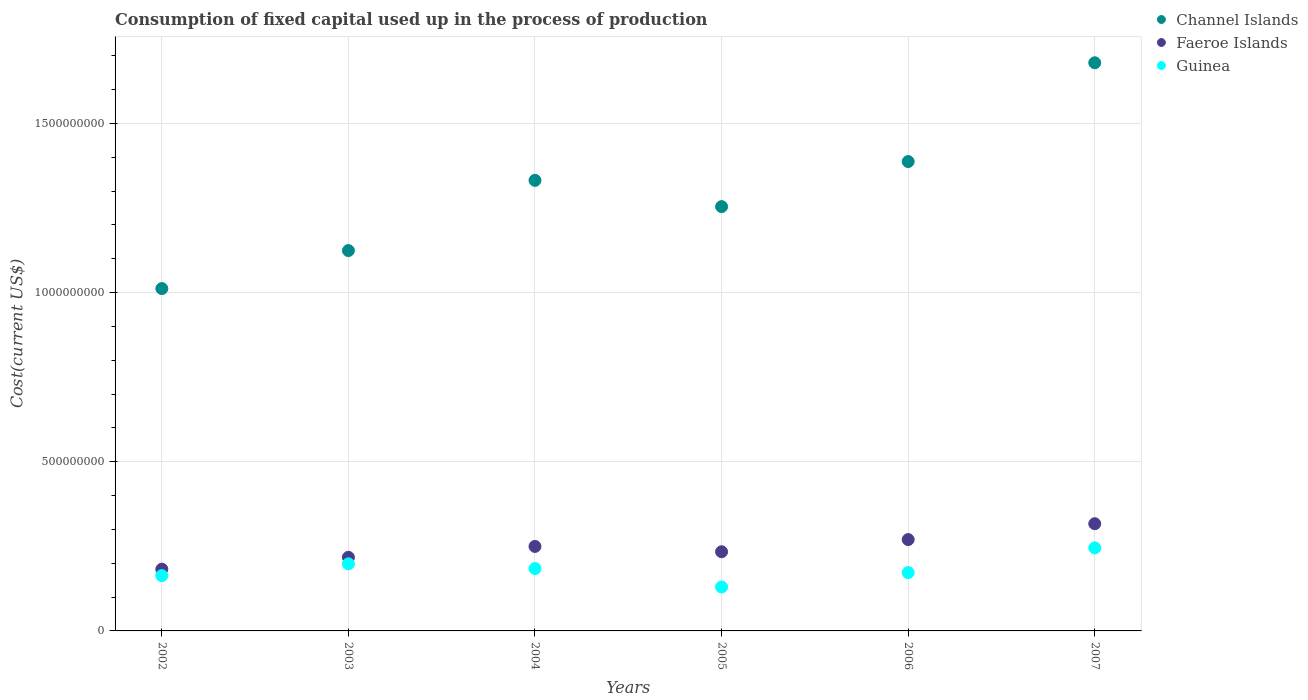Is the number of dotlines equal to the number of legend labels?
Provide a succinct answer. Yes. What is the amount consumed in the process of production in Guinea in 2005?
Your answer should be very brief. 1.30e+08. Across all years, what is the maximum amount consumed in the process of production in Channel Islands?
Ensure brevity in your answer.  1.68e+09. Across all years, what is the minimum amount consumed in the process of production in Faeroe Islands?
Your answer should be very brief. 1.83e+08. In which year was the amount consumed in the process of production in Faeroe Islands minimum?
Keep it short and to the point. 2002. What is the total amount consumed in the process of production in Guinea in the graph?
Keep it short and to the point. 1.09e+09. What is the difference between the amount consumed in the process of production in Faeroe Islands in 2003 and that in 2006?
Offer a very short reply. -5.24e+07. What is the difference between the amount consumed in the process of production in Channel Islands in 2006 and the amount consumed in the process of production in Guinea in 2003?
Provide a succinct answer. 1.19e+09. What is the average amount consumed in the process of production in Channel Islands per year?
Ensure brevity in your answer.  1.30e+09. In the year 2003, what is the difference between the amount consumed in the process of production in Guinea and amount consumed in the process of production in Channel Islands?
Your answer should be very brief. -9.26e+08. What is the ratio of the amount consumed in the process of production in Channel Islands in 2003 to that in 2006?
Offer a terse response. 0.81. What is the difference between the highest and the second highest amount consumed in the process of production in Channel Islands?
Keep it short and to the point. 2.92e+08. What is the difference between the highest and the lowest amount consumed in the process of production in Channel Islands?
Your answer should be very brief. 6.67e+08. Is it the case that in every year, the sum of the amount consumed in the process of production in Faeroe Islands and amount consumed in the process of production in Guinea  is greater than the amount consumed in the process of production in Channel Islands?
Make the answer very short. No. Is the amount consumed in the process of production in Guinea strictly greater than the amount consumed in the process of production in Channel Islands over the years?
Give a very brief answer. No. How many years are there in the graph?
Your response must be concise. 6. Does the graph contain any zero values?
Provide a short and direct response. No. Does the graph contain grids?
Keep it short and to the point. Yes. How many legend labels are there?
Offer a very short reply. 3. How are the legend labels stacked?
Give a very brief answer. Vertical. What is the title of the graph?
Ensure brevity in your answer.  Consumption of fixed capital used up in the process of production. Does "Turkmenistan" appear as one of the legend labels in the graph?
Provide a succinct answer. No. What is the label or title of the X-axis?
Make the answer very short. Years. What is the label or title of the Y-axis?
Ensure brevity in your answer.  Cost(current US$). What is the Cost(current US$) of Channel Islands in 2002?
Keep it short and to the point. 1.01e+09. What is the Cost(current US$) in Faeroe Islands in 2002?
Make the answer very short. 1.83e+08. What is the Cost(current US$) of Guinea in 2002?
Offer a terse response. 1.63e+08. What is the Cost(current US$) in Channel Islands in 2003?
Keep it short and to the point. 1.12e+09. What is the Cost(current US$) of Faeroe Islands in 2003?
Provide a succinct answer. 2.18e+08. What is the Cost(current US$) in Guinea in 2003?
Offer a terse response. 1.98e+08. What is the Cost(current US$) of Channel Islands in 2004?
Keep it short and to the point. 1.33e+09. What is the Cost(current US$) of Faeroe Islands in 2004?
Provide a short and direct response. 2.50e+08. What is the Cost(current US$) of Guinea in 2004?
Provide a short and direct response. 1.84e+08. What is the Cost(current US$) of Channel Islands in 2005?
Your answer should be very brief. 1.25e+09. What is the Cost(current US$) in Faeroe Islands in 2005?
Provide a short and direct response. 2.34e+08. What is the Cost(current US$) in Guinea in 2005?
Offer a very short reply. 1.30e+08. What is the Cost(current US$) of Channel Islands in 2006?
Keep it short and to the point. 1.39e+09. What is the Cost(current US$) of Faeroe Islands in 2006?
Offer a terse response. 2.70e+08. What is the Cost(current US$) in Guinea in 2006?
Keep it short and to the point. 1.72e+08. What is the Cost(current US$) in Channel Islands in 2007?
Your response must be concise. 1.68e+09. What is the Cost(current US$) in Faeroe Islands in 2007?
Offer a very short reply. 3.17e+08. What is the Cost(current US$) of Guinea in 2007?
Offer a terse response. 2.46e+08. Across all years, what is the maximum Cost(current US$) of Channel Islands?
Your answer should be very brief. 1.68e+09. Across all years, what is the maximum Cost(current US$) in Faeroe Islands?
Your answer should be very brief. 3.17e+08. Across all years, what is the maximum Cost(current US$) in Guinea?
Make the answer very short. 2.46e+08. Across all years, what is the minimum Cost(current US$) in Channel Islands?
Offer a terse response. 1.01e+09. Across all years, what is the minimum Cost(current US$) in Faeroe Islands?
Ensure brevity in your answer.  1.83e+08. Across all years, what is the minimum Cost(current US$) in Guinea?
Keep it short and to the point. 1.30e+08. What is the total Cost(current US$) in Channel Islands in the graph?
Your answer should be compact. 7.79e+09. What is the total Cost(current US$) in Faeroe Islands in the graph?
Keep it short and to the point. 1.47e+09. What is the total Cost(current US$) in Guinea in the graph?
Keep it short and to the point. 1.09e+09. What is the difference between the Cost(current US$) of Channel Islands in 2002 and that in 2003?
Make the answer very short. -1.12e+08. What is the difference between the Cost(current US$) in Faeroe Islands in 2002 and that in 2003?
Your answer should be very brief. -3.51e+07. What is the difference between the Cost(current US$) in Guinea in 2002 and that in 2003?
Your answer should be compact. -3.49e+07. What is the difference between the Cost(current US$) of Channel Islands in 2002 and that in 2004?
Make the answer very short. -3.20e+08. What is the difference between the Cost(current US$) in Faeroe Islands in 2002 and that in 2004?
Ensure brevity in your answer.  -6.72e+07. What is the difference between the Cost(current US$) of Guinea in 2002 and that in 2004?
Ensure brevity in your answer.  -2.11e+07. What is the difference between the Cost(current US$) of Channel Islands in 2002 and that in 2005?
Your answer should be very brief. -2.42e+08. What is the difference between the Cost(current US$) of Faeroe Islands in 2002 and that in 2005?
Your response must be concise. -5.15e+07. What is the difference between the Cost(current US$) in Guinea in 2002 and that in 2005?
Offer a terse response. 3.35e+07. What is the difference between the Cost(current US$) in Channel Islands in 2002 and that in 2006?
Keep it short and to the point. -3.76e+08. What is the difference between the Cost(current US$) in Faeroe Islands in 2002 and that in 2006?
Your answer should be very brief. -8.75e+07. What is the difference between the Cost(current US$) of Guinea in 2002 and that in 2006?
Your answer should be compact. -8.97e+06. What is the difference between the Cost(current US$) in Channel Islands in 2002 and that in 2007?
Make the answer very short. -6.67e+08. What is the difference between the Cost(current US$) of Faeroe Islands in 2002 and that in 2007?
Provide a succinct answer. -1.34e+08. What is the difference between the Cost(current US$) in Guinea in 2002 and that in 2007?
Your answer should be compact. -8.22e+07. What is the difference between the Cost(current US$) in Channel Islands in 2003 and that in 2004?
Offer a terse response. -2.08e+08. What is the difference between the Cost(current US$) of Faeroe Islands in 2003 and that in 2004?
Offer a terse response. -3.21e+07. What is the difference between the Cost(current US$) in Guinea in 2003 and that in 2004?
Your response must be concise. 1.39e+07. What is the difference between the Cost(current US$) of Channel Islands in 2003 and that in 2005?
Make the answer very short. -1.30e+08. What is the difference between the Cost(current US$) in Faeroe Islands in 2003 and that in 2005?
Give a very brief answer. -1.64e+07. What is the difference between the Cost(current US$) in Guinea in 2003 and that in 2005?
Your response must be concise. 6.85e+07. What is the difference between the Cost(current US$) in Channel Islands in 2003 and that in 2006?
Offer a terse response. -2.63e+08. What is the difference between the Cost(current US$) of Faeroe Islands in 2003 and that in 2006?
Provide a short and direct response. -5.24e+07. What is the difference between the Cost(current US$) of Guinea in 2003 and that in 2006?
Make the answer very short. 2.60e+07. What is the difference between the Cost(current US$) in Channel Islands in 2003 and that in 2007?
Keep it short and to the point. -5.55e+08. What is the difference between the Cost(current US$) of Faeroe Islands in 2003 and that in 2007?
Give a very brief answer. -9.93e+07. What is the difference between the Cost(current US$) of Guinea in 2003 and that in 2007?
Provide a succinct answer. -4.72e+07. What is the difference between the Cost(current US$) in Channel Islands in 2004 and that in 2005?
Provide a short and direct response. 7.76e+07. What is the difference between the Cost(current US$) in Faeroe Islands in 2004 and that in 2005?
Make the answer very short. 1.57e+07. What is the difference between the Cost(current US$) in Guinea in 2004 and that in 2005?
Offer a terse response. 5.46e+07. What is the difference between the Cost(current US$) in Channel Islands in 2004 and that in 2006?
Offer a very short reply. -5.56e+07. What is the difference between the Cost(current US$) in Faeroe Islands in 2004 and that in 2006?
Keep it short and to the point. -2.03e+07. What is the difference between the Cost(current US$) in Guinea in 2004 and that in 2006?
Provide a succinct answer. 1.21e+07. What is the difference between the Cost(current US$) in Channel Islands in 2004 and that in 2007?
Your answer should be compact. -3.48e+08. What is the difference between the Cost(current US$) of Faeroe Islands in 2004 and that in 2007?
Your answer should be compact. -6.72e+07. What is the difference between the Cost(current US$) in Guinea in 2004 and that in 2007?
Offer a very short reply. -6.11e+07. What is the difference between the Cost(current US$) in Channel Islands in 2005 and that in 2006?
Provide a succinct answer. -1.33e+08. What is the difference between the Cost(current US$) in Faeroe Islands in 2005 and that in 2006?
Ensure brevity in your answer.  -3.60e+07. What is the difference between the Cost(current US$) of Guinea in 2005 and that in 2006?
Your answer should be very brief. -4.25e+07. What is the difference between the Cost(current US$) of Channel Islands in 2005 and that in 2007?
Your answer should be very brief. -4.25e+08. What is the difference between the Cost(current US$) in Faeroe Islands in 2005 and that in 2007?
Keep it short and to the point. -8.29e+07. What is the difference between the Cost(current US$) in Guinea in 2005 and that in 2007?
Your response must be concise. -1.16e+08. What is the difference between the Cost(current US$) in Channel Islands in 2006 and that in 2007?
Offer a terse response. -2.92e+08. What is the difference between the Cost(current US$) of Faeroe Islands in 2006 and that in 2007?
Give a very brief answer. -4.69e+07. What is the difference between the Cost(current US$) in Guinea in 2006 and that in 2007?
Provide a succinct answer. -7.32e+07. What is the difference between the Cost(current US$) of Channel Islands in 2002 and the Cost(current US$) of Faeroe Islands in 2003?
Ensure brevity in your answer.  7.94e+08. What is the difference between the Cost(current US$) of Channel Islands in 2002 and the Cost(current US$) of Guinea in 2003?
Your answer should be very brief. 8.14e+08. What is the difference between the Cost(current US$) of Faeroe Islands in 2002 and the Cost(current US$) of Guinea in 2003?
Provide a succinct answer. -1.58e+07. What is the difference between the Cost(current US$) of Channel Islands in 2002 and the Cost(current US$) of Faeroe Islands in 2004?
Make the answer very short. 7.62e+08. What is the difference between the Cost(current US$) of Channel Islands in 2002 and the Cost(current US$) of Guinea in 2004?
Your response must be concise. 8.27e+08. What is the difference between the Cost(current US$) in Faeroe Islands in 2002 and the Cost(current US$) in Guinea in 2004?
Your answer should be compact. -1.89e+06. What is the difference between the Cost(current US$) in Channel Islands in 2002 and the Cost(current US$) in Faeroe Islands in 2005?
Your answer should be very brief. 7.78e+08. What is the difference between the Cost(current US$) in Channel Islands in 2002 and the Cost(current US$) in Guinea in 2005?
Offer a terse response. 8.82e+08. What is the difference between the Cost(current US$) of Faeroe Islands in 2002 and the Cost(current US$) of Guinea in 2005?
Give a very brief answer. 5.27e+07. What is the difference between the Cost(current US$) in Channel Islands in 2002 and the Cost(current US$) in Faeroe Islands in 2006?
Offer a terse response. 7.42e+08. What is the difference between the Cost(current US$) of Channel Islands in 2002 and the Cost(current US$) of Guinea in 2006?
Ensure brevity in your answer.  8.40e+08. What is the difference between the Cost(current US$) in Faeroe Islands in 2002 and the Cost(current US$) in Guinea in 2006?
Make the answer very short. 1.02e+07. What is the difference between the Cost(current US$) in Channel Islands in 2002 and the Cost(current US$) in Faeroe Islands in 2007?
Offer a terse response. 6.95e+08. What is the difference between the Cost(current US$) in Channel Islands in 2002 and the Cost(current US$) in Guinea in 2007?
Your answer should be compact. 7.66e+08. What is the difference between the Cost(current US$) in Faeroe Islands in 2002 and the Cost(current US$) in Guinea in 2007?
Your answer should be compact. -6.30e+07. What is the difference between the Cost(current US$) in Channel Islands in 2003 and the Cost(current US$) in Faeroe Islands in 2004?
Give a very brief answer. 8.75e+08. What is the difference between the Cost(current US$) of Channel Islands in 2003 and the Cost(current US$) of Guinea in 2004?
Your response must be concise. 9.40e+08. What is the difference between the Cost(current US$) in Faeroe Islands in 2003 and the Cost(current US$) in Guinea in 2004?
Keep it short and to the point. 3.32e+07. What is the difference between the Cost(current US$) of Channel Islands in 2003 and the Cost(current US$) of Faeroe Islands in 2005?
Your response must be concise. 8.90e+08. What is the difference between the Cost(current US$) in Channel Islands in 2003 and the Cost(current US$) in Guinea in 2005?
Give a very brief answer. 9.94e+08. What is the difference between the Cost(current US$) of Faeroe Islands in 2003 and the Cost(current US$) of Guinea in 2005?
Provide a succinct answer. 8.78e+07. What is the difference between the Cost(current US$) of Channel Islands in 2003 and the Cost(current US$) of Faeroe Islands in 2006?
Keep it short and to the point. 8.54e+08. What is the difference between the Cost(current US$) in Channel Islands in 2003 and the Cost(current US$) in Guinea in 2006?
Offer a terse response. 9.52e+08. What is the difference between the Cost(current US$) of Faeroe Islands in 2003 and the Cost(current US$) of Guinea in 2006?
Provide a short and direct response. 4.53e+07. What is the difference between the Cost(current US$) in Channel Islands in 2003 and the Cost(current US$) in Faeroe Islands in 2007?
Your answer should be compact. 8.07e+08. What is the difference between the Cost(current US$) of Channel Islands in 2003 and the Cost(current US$) of Guinea in 2007?
Your response must be concise. 8.79e+08. What is the difference between the Cost(current US$) of Faeroe Islands in 2003 and the Cost(current US$) of Guinea in 2007?
Give a very brief answer. -2.79e+07. What is the difference between the Cost(current US$) in Channel Islands in 2004 and the Cost(current US$) in Faeroe Islands in 2005?
Provide a short and direct response. 1.10e+09. What is the difference between the Cost(current US$) in Channel Islands in 2004 and the Cost(current US$) in Guinea in 2005?
Offer a terse response. 1.20e+09. What is the difference between the Cost(current US$) in Faeroe Islands in 2004 and the Cost(current US$) in Guinea in 2005?
Ensure brevity in your answer.  1.20e+08. What is the difference between the Cost(current US$) in Channel Islands in 2004 and the Cost(current US$) in Faeroe Islands in 2006?
Provide a succinct answer. 1.06e+09. What is the difference between the Cost(current US$) in Channel Islands in 2004 and the Cost(current US$) in Guinea in 2006?
Your answer should be compact. 1.16e+09. What is the difference between the Cost(current US$) in Faeroe Islands in 2004 and the Cost(current US$) in Guinea in 2006?
Ensure brevity in your answer.  7.74e+07. What is the difference between the Cost(current US$) of Channel Islands in 2004 and the Cost(current US$) of Faeroe Islands in 2007?
Your response must be concise. 1.01e+09. What is the difference between the Cost(current US$) of Channel Islands in 2004 and the Cost(current US$) of Guinea in 2007?
Offer a terse response. 1.09e+09. What is the difference between the Cost(current US$) in Faeroe Islands in 2004 and the Cost(current US$) in Guinea in 2007?
Offer a very short reply. 4.19e+06. What is the difference between the Cost(current US$) in Channel Islands in 2005 and the Cost(current US$) in Faeroe Islands in 2006?
Provide a short and direct response. 9.84e+08. What is the difference between the Cost(current US$) of Channel Islands in 2005 and the Cost(current US$) of Guinea in 2006?
Provide a succinct answer. 1.08e+09. What is the difference between the Cost(current US$) of Faeroe Islands in 2005 and the Cost(current US$) of Guinea in 2006?
Your response must be concise. 6.17e+07. What is the difference between the Cost(current US$) in Channel Islands in 2005 and the Cost(current US$) in Faeroe Islands in 2007?
Make the answer very short. 9.37e+08. What is the difference between the Cost(current US$) in Channel Islands in 2005 and the Cost(current US$) in Guinea in 2007?
Give a very brief answer. 1.01e+09. What is the difference between the Cost(current US$) in Faeroe Islands in 2005 and the Cost(current US$) in Guinea in 2007?
Ensure brevity in your answer.  -1.15e+07. What is the difference between the Cost(current US$) in Channel Islands in 2006 and the Cost(current US$) in Faeroe Islands in 2007?
Your response must be concise. 1.07e+09. What is the difference between the Cost(current US$) in Channel Islands in 2006 and the Cost(current US$) in Guinea in 2007?
Keep it short and to the point. 1.14e+09. What is the difference between the Cost(current US$) of Faeroe Islands in 2006 and the Cost(current US$) of Guinea in 2007?
Provide a succinct answer. 2.45e+07. What is the average Cost(current US$) in Channel Islands per year?
Your answer should be very brief. 1.30e+09. What is the average Cost(current US$) in Faeroe Islands per year?
Offer a terse response. 2.45e+08. What is the average Cost(current US$) of Guinea per year?
Give a very brief answer. 1.82e+08. In the year 2002, what is the difference between the Cost(current US$) in Channel Islands and Cost(current US$) in Faeroe Islands?
Give a very brief answer. 8.29e+08. In the year 2002, what is the difference between the Cost(current US$) of Channel Islands and Cost(current US$) of Guinea?
Give a very brief answer. 8.49e+08. In the year 2002, what is the difference between the Cost(current US$) of Faeroe Islands and Cost(current US$) of Guinea?
Offer a terse response. 1.92e+07. In the year 2003, what is the difference between the Cost(current US$) of Channel Islands and Cost(current US$) of Faeroe Islands?
Provide a short and direct response. 9.07e+08. In the year 2003, what is the difference between the Cost(current US$) of Channel Islands and Cost(current US$) of Guinea?
Keep it short and to the point. 9.26e+08. In the year 2003, what is the difference between the Cost(current US$) of Faeroe Islands and Cost(current US$) of Guinea?
Make the answer very short. 1.93e+07. In the year 2004, what is the difference between the Cost(current US$) in Channel Islands and Cost(current US$) in Faeroe Islands?
Make the answer very short. 1.08e+09. In the year 2004, what is the difference between the Cost(current US$) of Channel Islands and Cost(current US$) of Guinea?
Keep it short and to the point. 1.15e+09. In the year 2004, what is the difference between the Cost(current US$) in Faeroe Islands and Cost(current US$) in Guinea?
Your answer should be very brief. 6.53e+07. In the year 2005, what is the difference between the Cost(current US$) of Channel Islands and Cost(current US$) of Faeroe Islands?
Offer a very short reply. 1.02e+09. In the year 2005, what is the difference between the Cost(current US$) of Channel Islands and Cost(current US$) of Guinea?
Give a very brief answer. 1.12e+09. In the year 2005, what is the difference between the Cost(current US$) of Faeroe Islands and Cost(current US$) of Guinea?
Give a very brief answer. 1.04e+08. In the year 2006, what is the difference between the Cost(current US$) in Channel Islands and Cost(current US$) in Faeroe Islands?
Your answer should be very brief. 1.12e+09. In the year 2006, what is the difference between the Cost(current US$) of Channel Islands and Cost(current US$) of Guinea?
Ensure brevity in your answer.  1.22e+09. In the year 2006, what is the difference between the Cost(current US$) of Faeroe Islands and Cost(current US$) of Guinea?
Your response must be concise. 9.77e+07. In the year 2007, what is the difference between the Cost(current US$) in Channel Islands and Cost(current US$) in Faeroe Islands?
Your answer should be very brief. 1.36e+09. In the year 2007, what is the difference between the Cost(current US$) in Channel Islands and Cost(current US$) in Guinea?
Give a very brief answer. 1.43e+09. In the year 2007, what is the difference between the Cost(current US$) of Faeroe Islands and Cost(current US$) of Guinea?
Offer a terse response. 7.14e+07. What is the ratio of the Cost(current US$) of Channel Islands in 2002 to that in 2003?
Your answer should be compact. 0.9. What is the ratio of the Cost(current US$) of Faeroe Islands in 2002 to that in 2003?
Offer a terse response. 0.84. What is the ratio of the Cost(current US$) in Guinea in 2002 to that in 2003?
Your answer should be compact. 0.82. What is the ratio of the Cost(current US$) of Channel Islands in 2002 to that in 2004?
Make the answer very short. 0.76. What is the ratio of the Cost(current US$) in Faeroe Islands in 2002 to that in 2004?
Keep it short and to the point. 0.73. What is the ratio of the Cost(current US$) of Guinea in 2002 to that in 2004?
Keep it short and to the point. 0.89. What is the ratio of the Cost(current US$) in Channel Islands in 2002 to that in 2005?
Provide a succinct answer. 0.81. What is the ratio of the Cost(current US$) of Faeroe Islands in 2002 to that in 2005?
Make the answer very short. 0.78. What is the ratio of the Cost(current US$) of Guinea in 2002 to that in 2005?
Your answer should be compact. 1.26. What is the ratio of the Cost(current US$) of Channel Islands in 2002 to that in 2006?
Offer a very short reply. 0.73. What is the ratio of the Cost(current US$) in Faeroe Islands in 2002 to that in 2006?
Give a very brief answer. 0.68. What is the ratio of the Cost(current US$) in Guinea in 2002 to that in 2006?
Keep it short and to the point. 0.95. What is the ratio of the Cost(current US$) in Channel Islands in 2002 to that in 2007?
Provide a succinct answer. 0.6. What is the ratio of the Cost(current US$) of Faeroe Islands in 2002 to that in 2007?
Ensure brevity in your answer.  0.58. What is the ratio of the Cost(current US$) of Guinea in 2002 to that in 2007?
Provide a succinct answer. 0.67. What is the ratio of the Cost(current US$) of Channel Islands in 2003 to that in 2004?
Make the answer very short. 0.84. What is the ratio of the Cost(current US$) of Faeroe Islands in 2003 to that in 2004?
Provide a short and direct response. 0.87. What is the ratio of the Cost(current US$) of Guinea in 2003 to that in 2004?
Offer a terse response. 1.08. What is the ratio of the Cost(current US$) of Channel Islands in 2003 to that in 2005?
Your answer should be compact. 0.9. What is the ratio of the Cost(current US$) in Faeroe Islands in 2003 to that in 2005?
Provide a succinct answer. 0.93. What is the ratio of the Cost(current US$) in Guinea in 2003 to that in 2005?
Your response must be concise. 1.53. What is the ratio of the Cost(current US$) in Channel Islands in 2003 to that in 2006?
Provide a short and direct response. 0.81. What is the ratio of the Cost(current US$) in Faeroe Islands in 2003 to that in 2006?
Your response must be concise. 0.81. What is the ratio of the Cost(current US$) of Guinea in 2003 to that in 2006?
Your answer should be very brief. 1.15. What is the ratio of the Cost(current US$) of Channel Islands in 2003 to that in 2007?
Offer a terse response. 0.67. What is the ratio of the Cost(current US$) of Faeroe Islands in 2003 to that in 2007?
Offer a very short reply. 0.69. What is the ratio of the Cost(current US$) in Guinea in 2003 to that in 2007?
Provide a succinct answer. 0.81. What is the ratio of the Cost(current US$) of Channel Islands in 2004 to that in 2005?
Your answer should be compact. 1.06. What is the ratio of the Cost(current US$) in Faeroe Islands in 2004 to that in 2005?
Provide a succinct answer. 1.07. What is the ratio of the Cost(current US$) in Guinea in 2004 to that in 2005?
Your response must be concise. 1.42. What is the ratio of the Cost(current US$) of Channel Islands in 2004 to that in 2006?
Your answer should be compact. 0.96. What is the ratio of the Cost(current US$) in Faeroe Islands in 2004 to that in 2006?
Offer a terse response. 0.92. What is the ratio of the Cost(current US$) of Guinea in 2004 to that in 2006?
Offer a terse response. 1.07. What is the ratio of the Cost(current US$) of Channel Islands in 2004 to that in 2007?
Offer a very short reply. 0.79. What is the ratio of the Cost(current US$) of Faeroe Islands in 2004 to that in 2007?
Offer a terse response. 0.79. What is the ratio of the Cost(current US$) of Guinea in 2004 to that in 2007?
Provide a short and direct response. 0.75. What is the ratio of the Cost(current US$) of Channel Islands in 2005 to that in 2006?
Your response must be concise. 0.9. What is the ratio of the Cost(current US$) of Faeroe Islands in 2005 to that in 2006?
Keep it short and to the point. 0.87. What is the ratio of the Cost(current US$) in Guinea in 2005 to that in 2006?
Your answer should be very brief. 0.75. What is the ratio of the Cost(current US$) of Channel Islands in 2005 to that in 2007?
Your answer should be compact. 0.75. What is the ratio of the Cost(current US$) of Faeroe Islands in 2005 to that in 2007?
Your answer should be very brief. 0.74. What is the ratio of the Cost(current US$) of Guinea in 2005 to that in 2007?
Make the answer very short. 0.53. What is the ratio of the Cost(current US$) of Channel Islands in 2006 to that in 2007?
Provide a succinct answer. 0.83. What is the ratio of the Cost(current US$) in Faeroe Islands in 2006 to that in 2007?
Your answer should be very brief. 0.85. What is the ratio of the Cost(current US$) of Guinea in 2006 to that in 2007?
Your answer should be compact. 0.7. What is the difference between the highest and the second highest Cost(current US$) of Channel Islands?
Make the answer very short. 2.92e+08. What is the difference between the highest and the second highest Cost(current US$) of Faeroe Islands?
Keep it short and to the point. 4.69e+07. What is the difference between the highest and the second highest Cost(current US$) in Guinea?
Provide a succinct answer. 4.72e+07. What is the difference between the highest and the lowest Cost(current US$) in Channel Islands?
Keep it short and to the point. 6.67e+08. What is the difference between the highest and the lowest Cost(current US$) of Faeroe Islands?
Your answer should be compact. 1.34e+08. What is the difference between the highest and the lowest Cost(current US$) of Guinea?
Make the answer very short. 1.16e+08. 